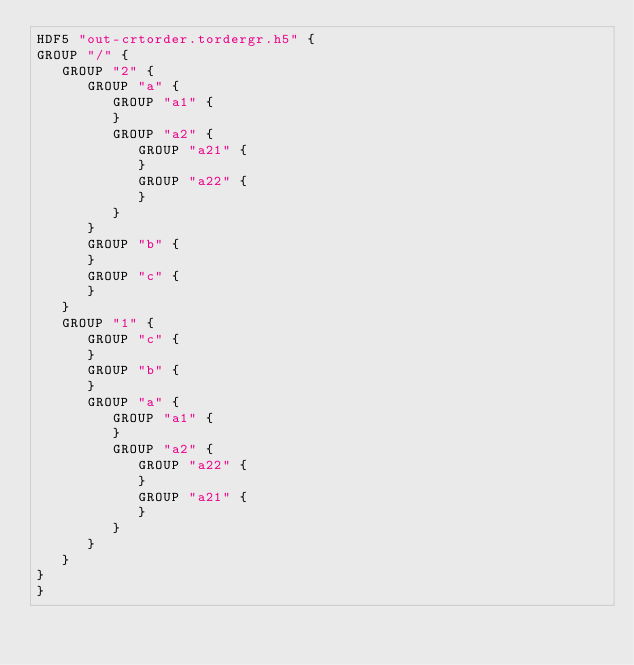<code> <loc_0><loc_0><loc_500><loc_500><_SQL_>HDF5 "out-crtorder.tordergr.h5" {
GROUP "/" {
   GROUP "2" {
      GROUP "a" {
         GROUP "a1" {
         }
         GROUP "a2" {
            GROUP "a21" {
            }
            GROUP "a22" {
            }
         }
      }
      GROUP "b" {
      }
      GROUP "c" {
      }
   }
   GROUP "1" {
      GROUP "c" {
      }
      GROUP "b" {
      }
      GROUP "a" {
         GROUP "a1" {
         }
         GROUP "a2" {
            GROUP "a22" {
            }
            GROUP "a21" {
            }
         }
      }
   }
}
}
</code> 